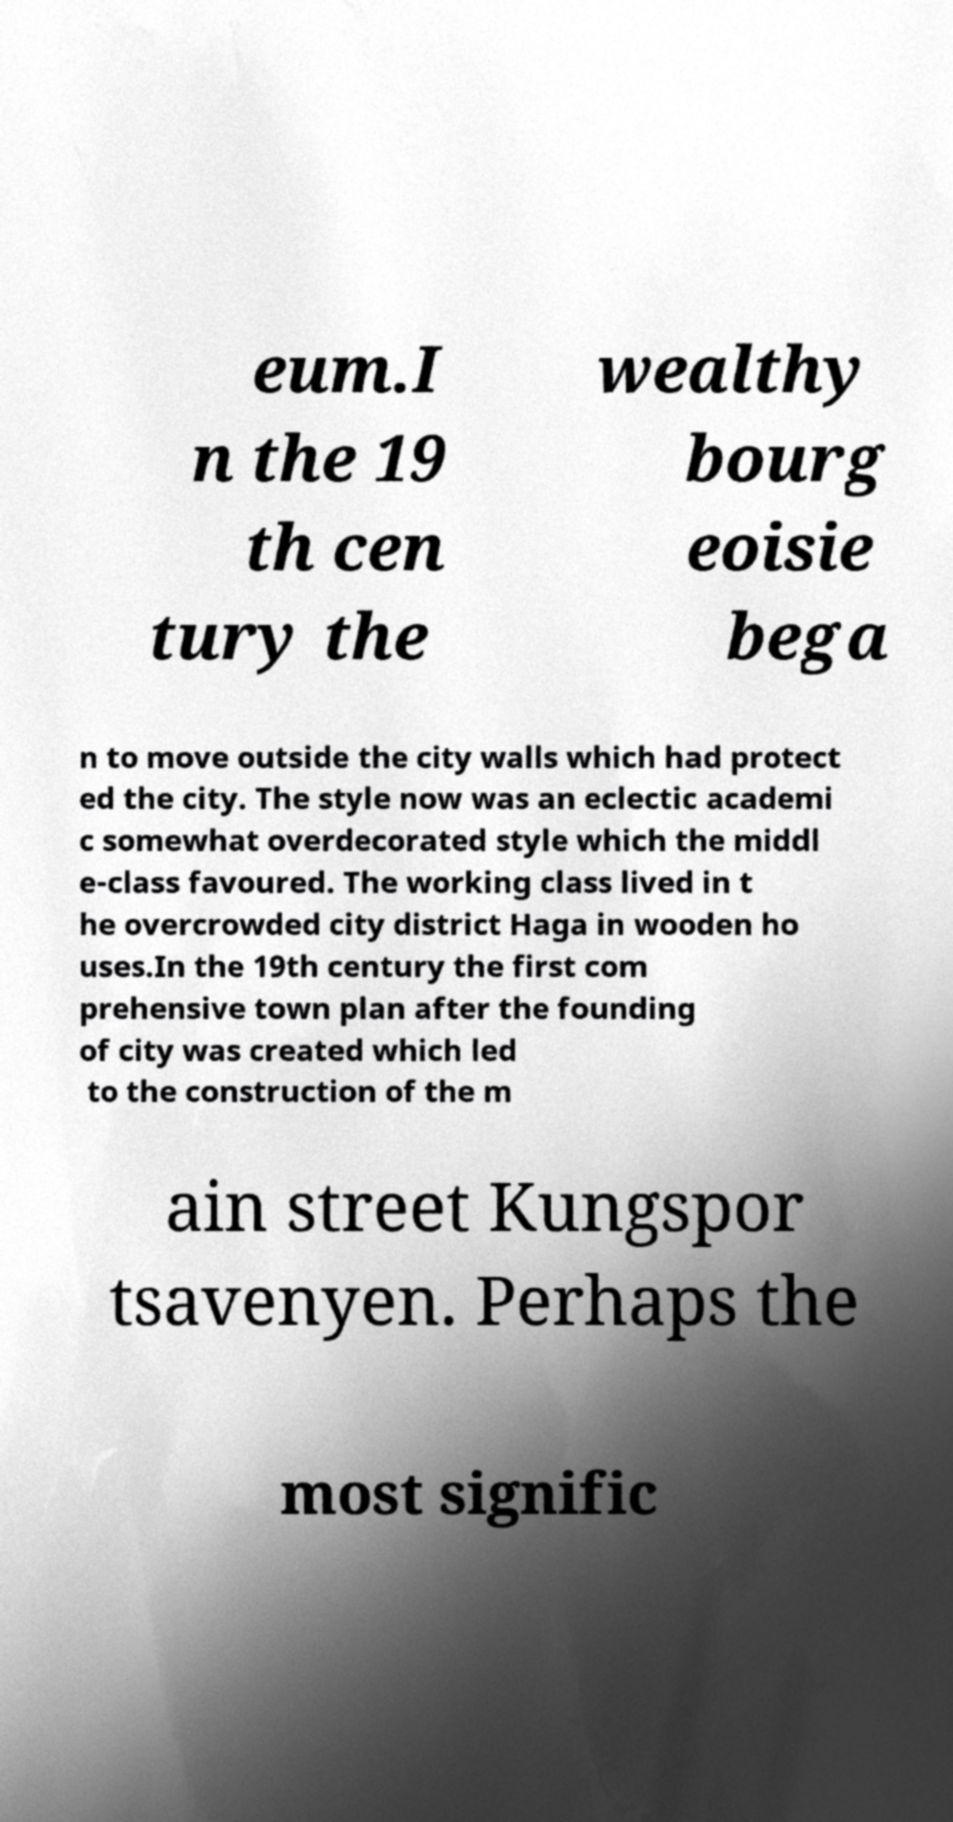What messages or text are displayed in this image? I need them in a readable, typed format. eum.I n the 19 th cen tury the wealthy bourg eoisie bega n to move outside the city walls which had protect ed the city. The style now was an eclectic academi c somewhat overdecorated style which the middl e-class favoured. The working class lived in t he overcrowded city district Haga in wooden ho uses.In the 19th century the first com prehensive town plan after the founding of city was created which led to the construction of the m ain street Kungspor tsavenyen. Perhaps the most signific 